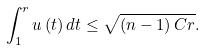Convert formula to latex. <formula><loc_0><loc_0><loc_500><loc_500>\int _ { 1 } ^ { r } u \left ( t \right ) d t \leq \sqrt { \left ( n - 1 \right ) C r } .</formula> 